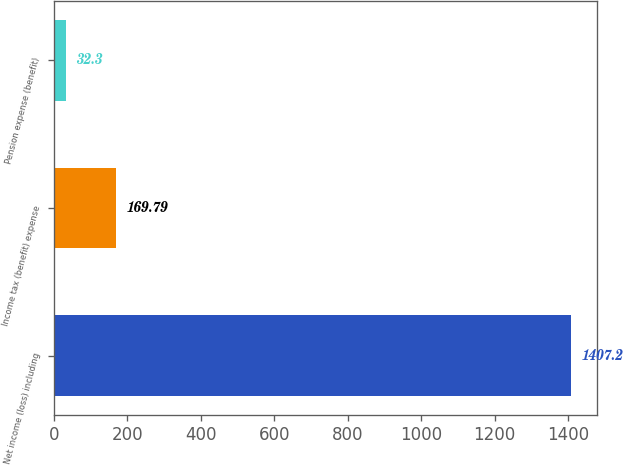Convert chart. <chart><loc_0><loc_0><loc_500><loc_500><bar_chart><fcel>Net income (loss) including<fcel>Income tax (benefit) expense<fcel>Pension expense (benefit)<nl><fcel>1407.2<fcel>169.79<fcel>32.3<nl></chart> 